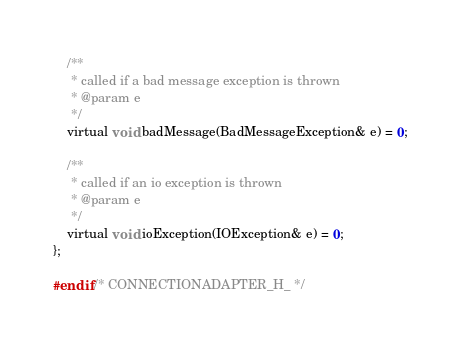<code> <loc_0><loc_0><loc_500><loc_500><_C_>	/**
	 * called if a bad message exception is thrown
	 * @param e
	 */
	virtual void badMessage(BadMessageException& e) = 0;

	/**
	 * called if an io exception is thrown
	 * @param e
	 */
	virtual void ioException(IOException& e) = 0;
};

#endif /* CONNECTIONADAPTER_H_ */
</code> 